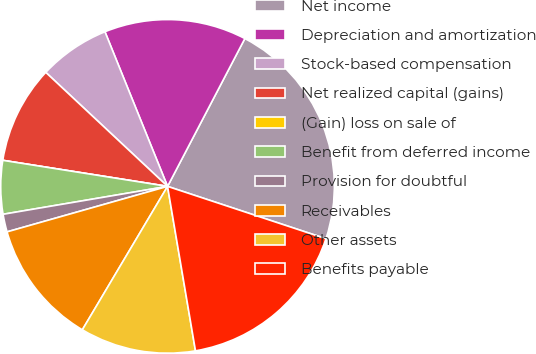<chart> <loc_0><loc_0><loc_500><loc_500><pie_chart><fcel>Net income<fcel>Depreciation and amortization<fcel>Stock-based compensation<fcel>Net realized capital (gains)<fcel>(Gain) loss on sale of<fcel>Benefit from deferred income<fcel>Provision for doubtful<fcel>Receivables<fcel>Other assets<fcel>Benefits payable<nl><fcel>22.41%<fcel>13.79%<fcel>6.9%<fcel>9.48%<fcel>0.0%<fcel>5.17%<fcel>1.72%<fcel>12.07%<fcel>11.21%<fcel>17.24%<nl></chart> 